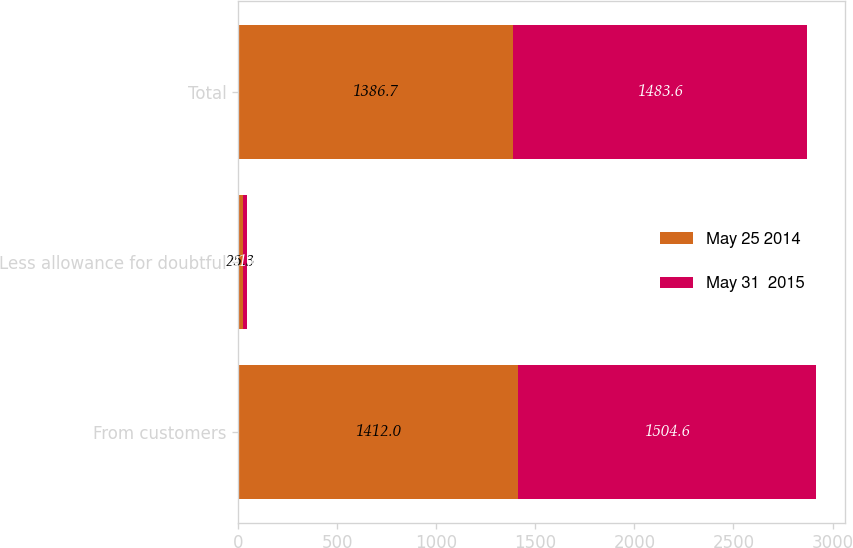Convert chart. <chart><loc_0><loc_0><loc_500><loc_500><stacked_bar_chart><ecel><fcel>From customers<fcel>Less allowance for doubtful<fcel>Total<nl><fcel>May 25 2014<fcel>1412<fcel>25.3<fcel>1386.7<nl><fcel>May 31  2015<fcel>1504.6<fcel>21<fcel>1483.6<nl></chart> 